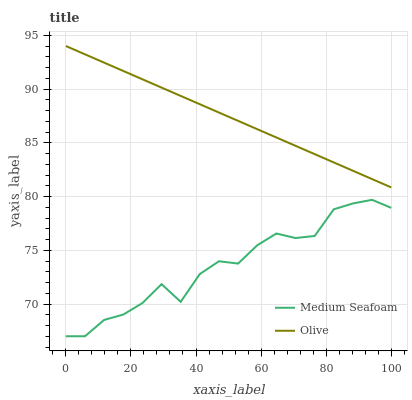Does Medium Seafoam have the minimum area under the curve?
Answer yes or no. Yes. Does Olive have the maximum area under the curve?
Answer yes or no. Yes. Does Medium Seafoam have the maximum area under the curve?
Answer yes or no. No. Is Olive the smoothest?
Answer yes or no. Yes. Is Medium Seafoam the roughest?
Answer yes or no. Yes. Is Medium Seafoam the smoothest?
Answer yes or no. No. Does Medium Seafoam have the lowest value?
Answer yes or no. Yes. Does Olive have the highest value?
Answer yes or no. Yes. Does Medium Seafoam have the highest value?
Answer yes or no. No. Is Medium Seafoam less than Olive?
Answer yes or no. Yes. Is Olive greater than Medium Seafoam?
Answer yes or no. Yes. Does Medium Seafoam intersect Olive?
Answer yes or no. No. 